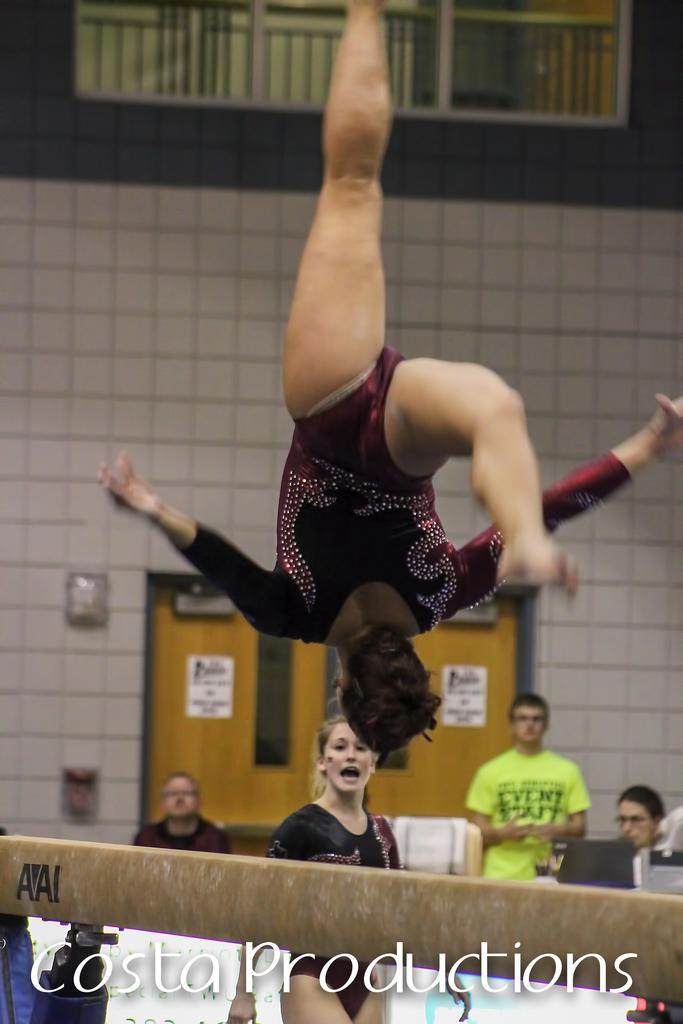In one or two sentences, can you explain what this image depicts? In the center of the image there is a woman flipping in air. In the background of the image there is a wall. There are people in the image. 